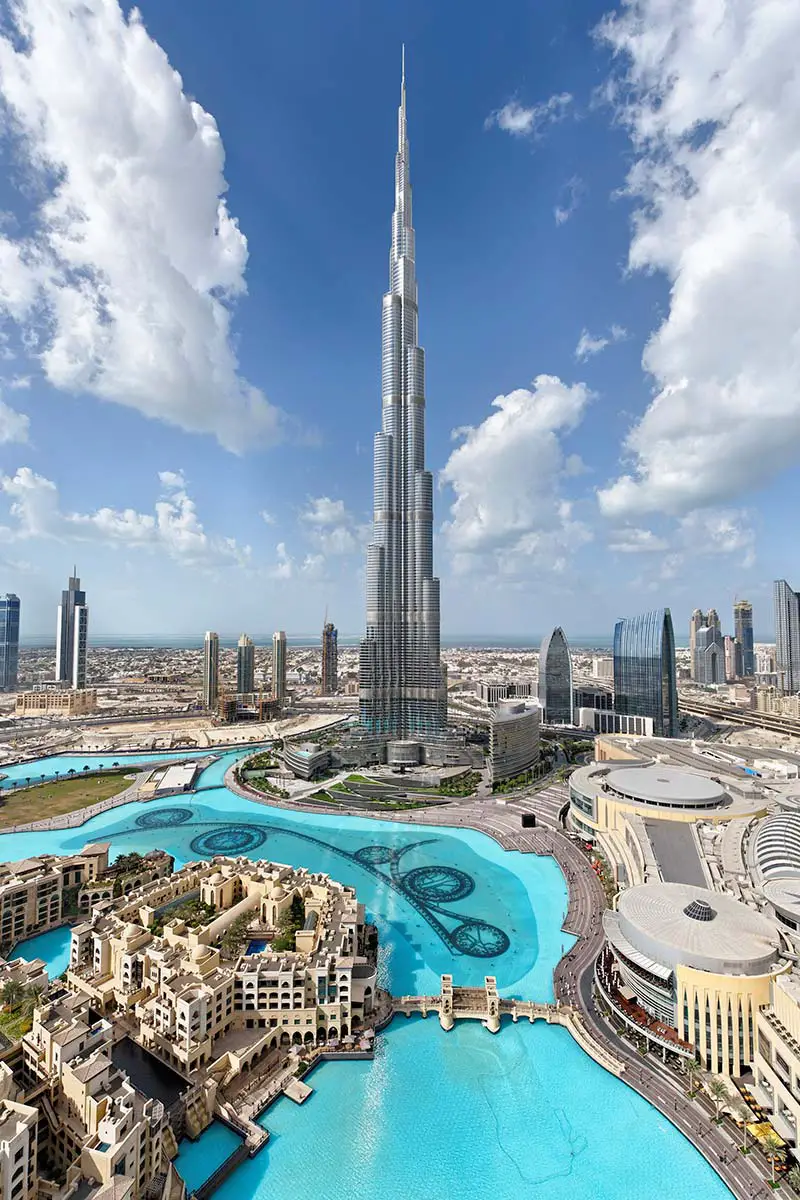Imagine if Burj Khalifa could talk. What stories would it tell? If the Burj Khalifa could talk, it would narrate tales of ambition and triumph. It would recall the efforts of the thousands of workers and engineers who toiled day and night to bring it to life. It would tell stories of witnessing historical events, like New Year’s Eve celebrations with fireworks lighting up the sky. It would speak of the diverse people from around the globe who came to admire its splendor, each leaving with their own story. Through its towering presence, it has seen Dubai grow from a humble trading port to a symbol of futuristic advancement. Each level reached high into the heavens is a chapter written in the saga of human ingenuity and determination. 